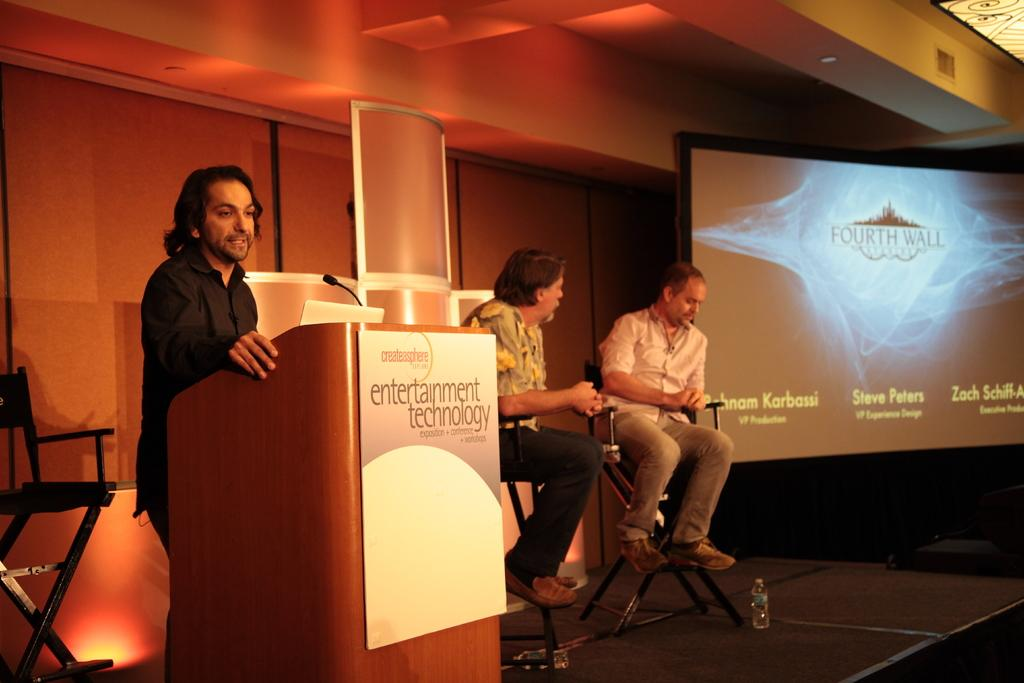<image>
Render a clear and concise summary of the photo. Three men on a stage giving a presentation on entertainment technology. 